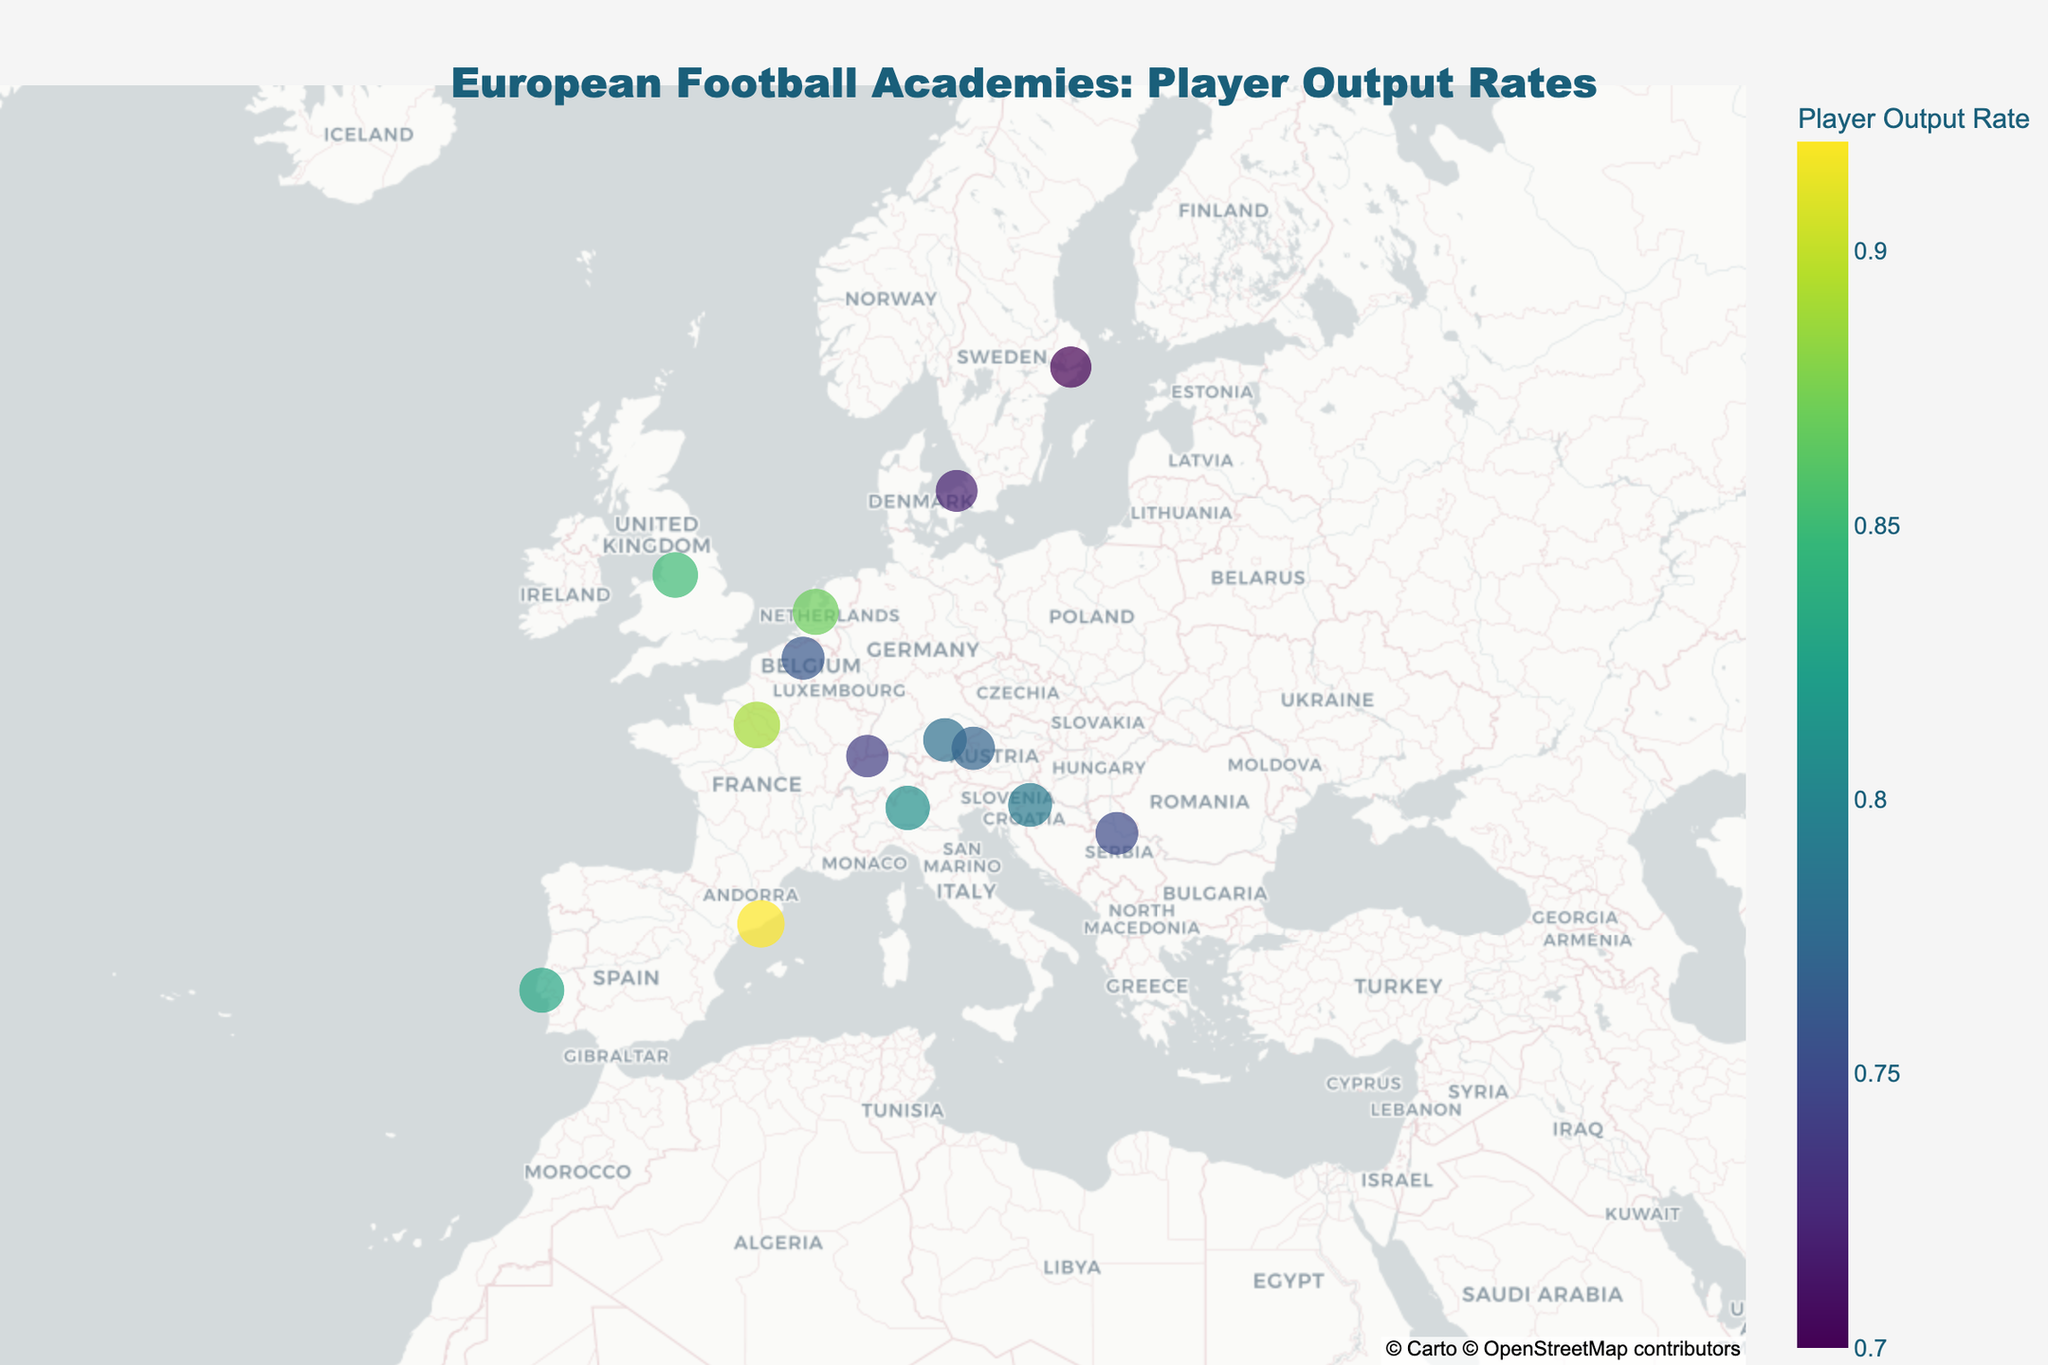How many football academies are displayed on the map? The visual shows several markers, each representing a football academy in Europe. Count the markers to determine the number of academies.
Answer: 13 Which academy has the highest player output rate? By examining the size and color of the markers, identify the academy with the most prominent size and darkest color, which indicates the highest player output rate.
Answer: La Masia (FC Barcelona) What is the average player output rate of all the academies? Sum the player output rates of all 13 academies and then divide by the number of academies: (0.85 + 0.92 + 0.78 + 0.89 + 0.87 + 0.83 + 0.76 + 0.81 + 0.79 + 0.75 + 0.77 + 0.72 + 0.70) / 13.
Answer: 0.80 Do any two academies have the same player output rate? Compare the player output rates of all academies to check for any identical values.
Answer: No Which country has the most football academies represented on the map? Look at the hover data or count the occurrences of each country’s name to see which one appears most frequently.
Answer: None is repeated What is the player output rate difference between Red Bull Salzburg Academy and FC Basel Youth Campus? Subtract the player output rate of FC Basel (0.74) from Red Bull Salzburg Academy (0.77): 0.77 - 0.74.
Answer: 0.03 Which academy is located furthest north? Identify the marker with the highest latitude value.
Answer: AIK Fotboll Youth Academy Is there an academy in the top three player output rates located outside the traditional top footballing countries (England, Spain, Germany, France, Italy)? Review the player output rates and corresponding countries; check if any top three academies are from non-traditional top footballing countries. La Masia (Spain), Clairefontaine (France), and Ajax Youth Academy (Netherlands) are the top three. The Netherlands is not traditionally a top footballing country.
Answer: Yes, Ajax Youth Academy (Netherlands) Which academy is closest to the geographical center of Europe? Visually estimate the central point of Europe and identify the marker nearest to it, considering latitude and longitude.
Answer: Anderlecht Youth Academy (Belgium) What is the combined player output rate of all academies located in countries starting with the letter 'S'? Sum the player output rates of La Masia (Spain), Sporting CP Academy (Portugal), and FC Basel Youth Campus (Switzerland): 0.92 + 0.83 + 0.74.
Answer: 2.49 